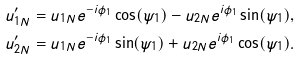Convert formula to latex. <formula><loc_0><loc_0><loc_500><loc_500>u _ { 1 N } ^ { \prime } & = u _ { 1 N } e ^ { - i \phi _ { 1 } } \cos ( \psi _ { 1 } ) - u _ { 2 N } e ^ { i \phi _ { 1 } } \sin ( \psi _ { 1 } ) , \\ u _ { 2 N } ^ { \prime } & = u _ { 1 N } e ^ { - i \phi _ { 1 } } \sin ( \psi _ { 1 } ) + u _ { 2 N } e ^ { i \phi _ { 1 } } \cos ( \psi _ { 1 } ) .</formula> 